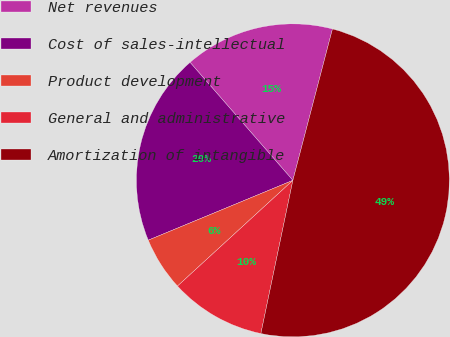Convert chart. <chart><loc_0><loc_0><loc_500><loc_500><pie_chart><fcel>Net revenues<fcel>Cost of sales-intellectual<fcel>Product development<fcel>General and administrative<fcel>Amortization of intangible<nl><fcel>15.48%<fcel>19.84%<fcel>5.56%<fcel>9.92%<fcel>49.21%<nl></chart> 